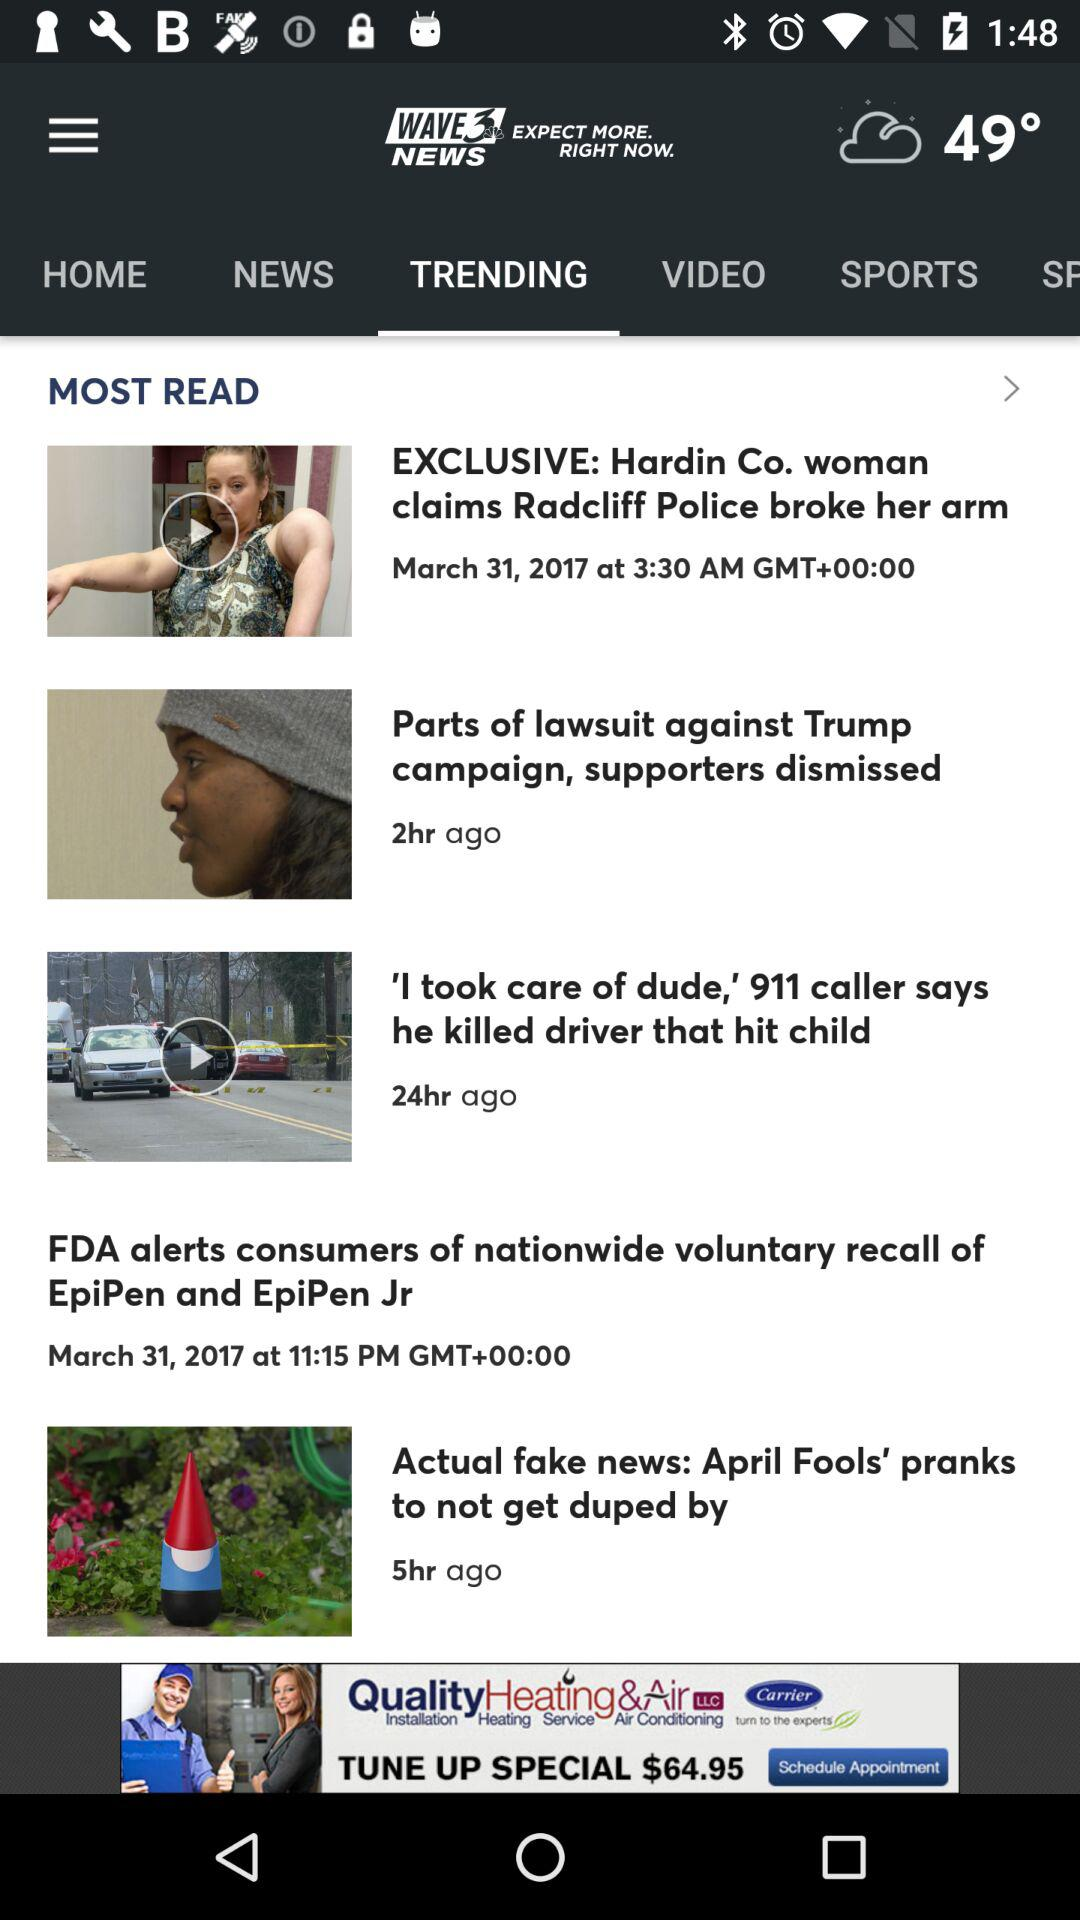Which tab is selected? The selected tab is "TRENDING". 